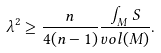Convert formula to latex. <formula><loc_0><loc_0><loc_500><loc_500>\lambda ^ { 2 } \geq \frac { n } { 4 ( n - 1 ) } \frac { \int _ { M } S } { v o l ( M ) } .</formula> 